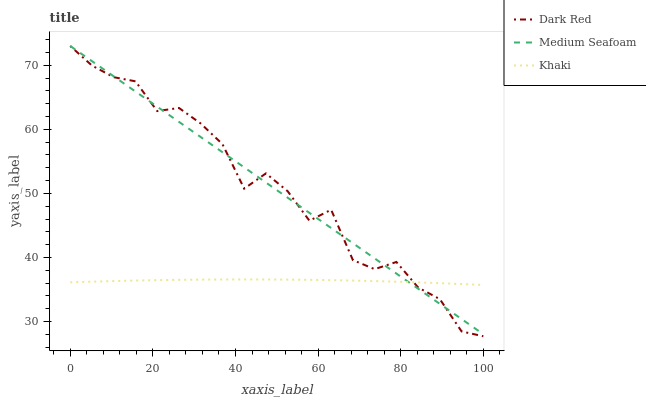Does Khaki have the minimum area under the curve?
Answer yes or no. Yes. Does Dark Red have the maximum area under the curve?
Answer yes or no. Yes. Does Medium Seafoam have the minimum area under the curve?
Answer yes or no. No. Does Medium Seafoam have the maximum area under the curve?
Answer yes or no. No. Is Medium Seafoam the smoothest?
Answer yes or no. Yes. Is Dark Red the roughest?
Answer yes or no. Yes. Is Khaki the smoothest?
Answer yes or no. No. Is Khaki the roughest?
Answer yes or no. No. Does Dark Red have the lowest value?
Answer yes or no. Yes. Does Medium Seafoam have the lowest value?
Answer yes or no. No. Does Medium Seafoam have the highest value?
Answer yes or no. Yes. Does Khaki have the highest value?
Answer yes or no. No. Does Medium Seafoam intersect Khaki?
Answer yes or no. Yes. Is Medium Seafoam less than Khaki?
Answer yes or no. No. Is Medium Seafoam greater than Khaki?
Answer yes or no. No. 